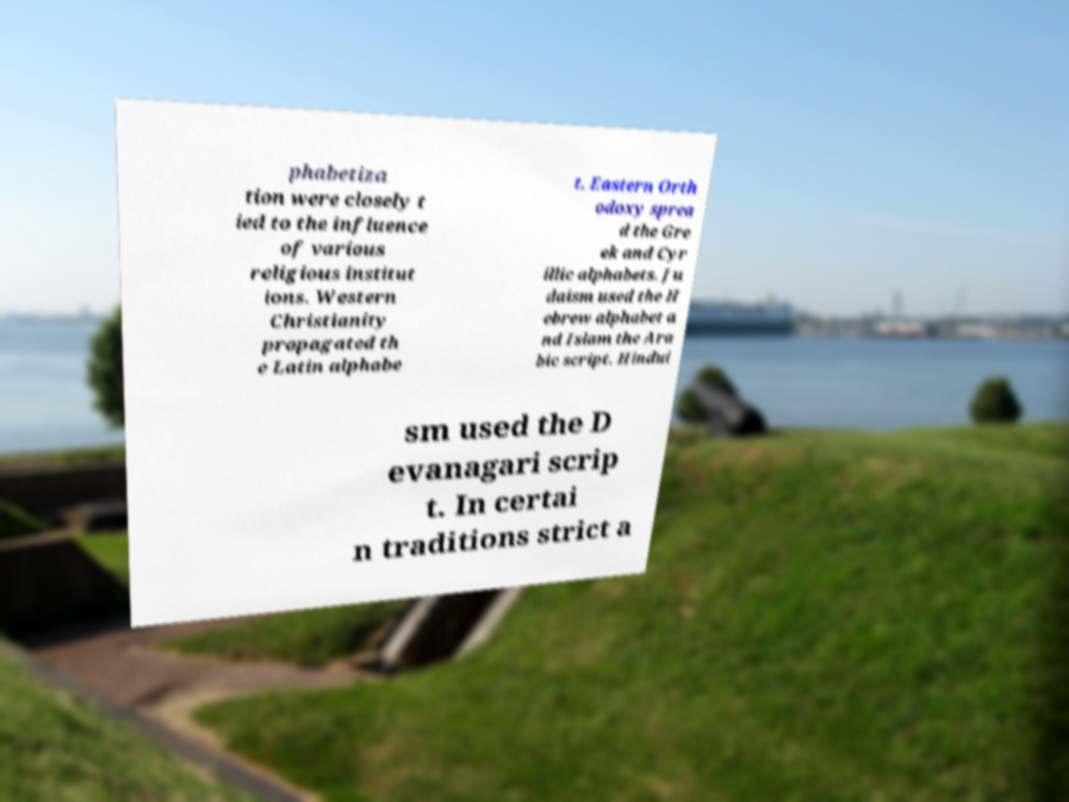Could you extract and type out the text from this image? phabetiza tion were closely t ied to the influence of various religious institut ions. Western Christianity propagated th e Latin alphabe t. Eastern Orth odoxy sprea d the Gre ek and Cyr illic alphabets. Ju daism used the H ebrew alphabet a nd Islam the Ara bic script. Hindui sm used the D evanagari scrip t. In certai n traditions strict a 